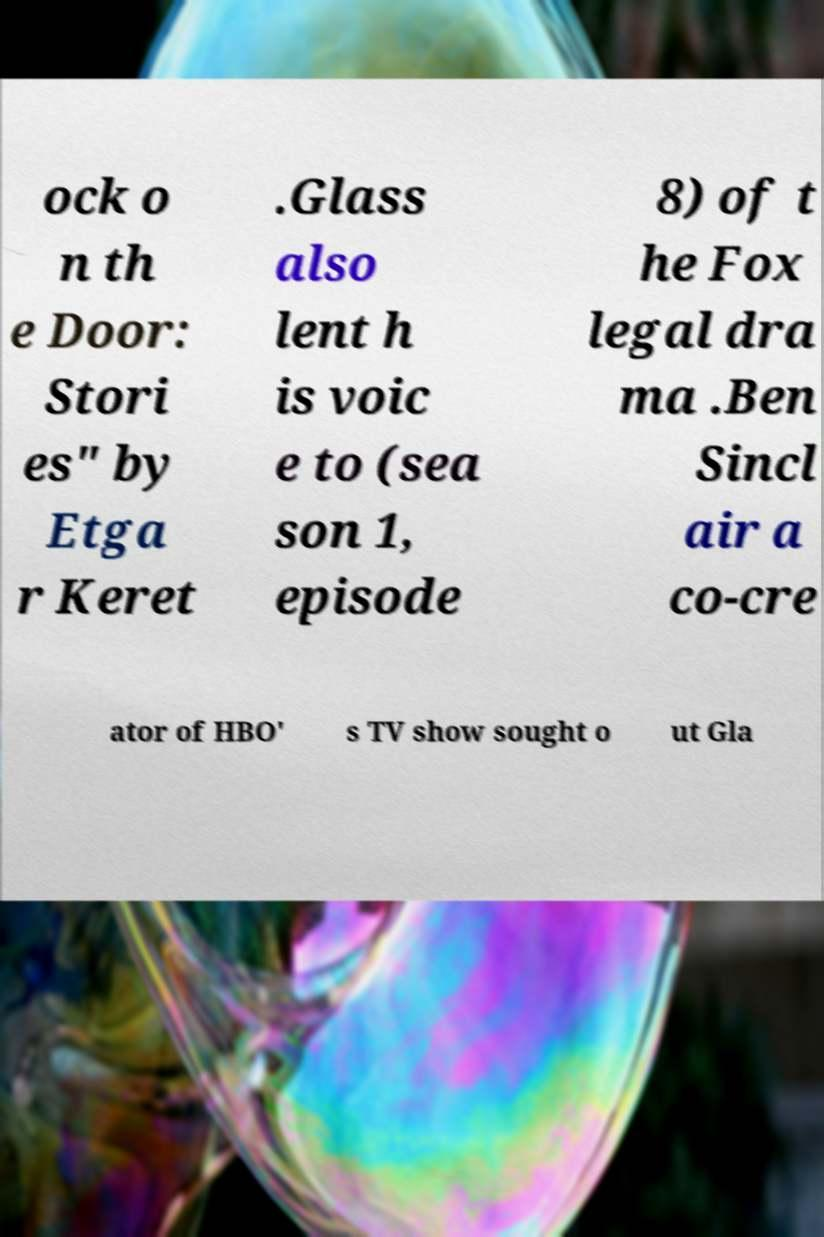Could you assist in decoding the text presented in this image and type it out clearly? ock o n th e Door: Stori es" by Etga r Keret .Glass also lent h is voic e to (sea son 1, episode 8) of t he Fox legal dra ma .Ben Sincl air a co-cre ator of HBO' s TV show sought o ut Gla 